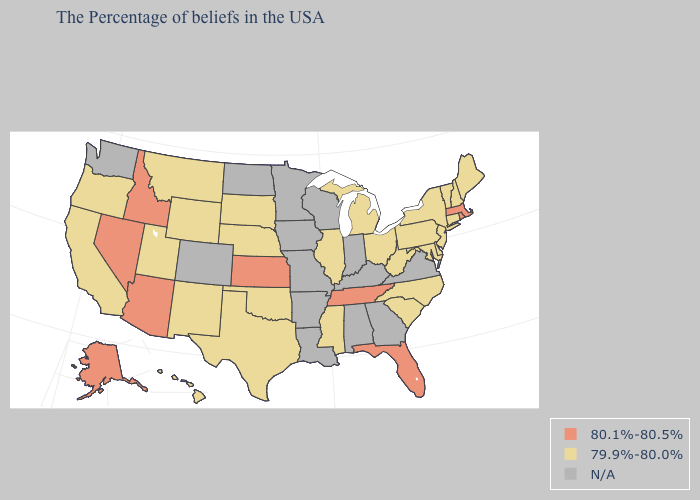Name the states that have a value in the range N/A?
Short answer required. Virginia, Georgia, Kentucky, Indiana, Alabama, Wisconsin, Louisiana, Missouri, Arkansas, Minnesota, Iowa, North Dakota, Colorado, Washington. Is the legend a continuous bar?
Be succinct. No. What is the highest value in the West ?
Answer briefly. 80.1%-80.5%. What is the value of Idaho?
Quick response, please. 80.1%-80.5%. What is the value of Tennessee?
Write a very short answer. 80.1%-80.5%. Among the states that border California , which have the lowest value?
Answer briefly. Oregon. What is the highest value in the USA?
Be succinct. 80.1%-80.5%. What is the value of Maine?
Keep it brief. 79.9%-80.0%. What is the lowest value in states that border Montana?
Short answer required. 79.9%-80.0%. Among the states that border Arkansas , does Texas have the lowest value?
Keep it brief. Yes. Name the states that have a value in the range N/A?
Quick response, please. Virginia, Georgia, Kentucky, Indiana, Alabama, Wisconsin, Louisiana, Missouri, Arkansas, Minnesota, Iowa, North Dakota, Colorado, Washington. 